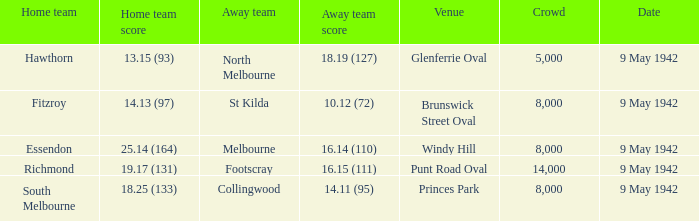What was the attendance for the game in which the home team scored 1 1.0. 